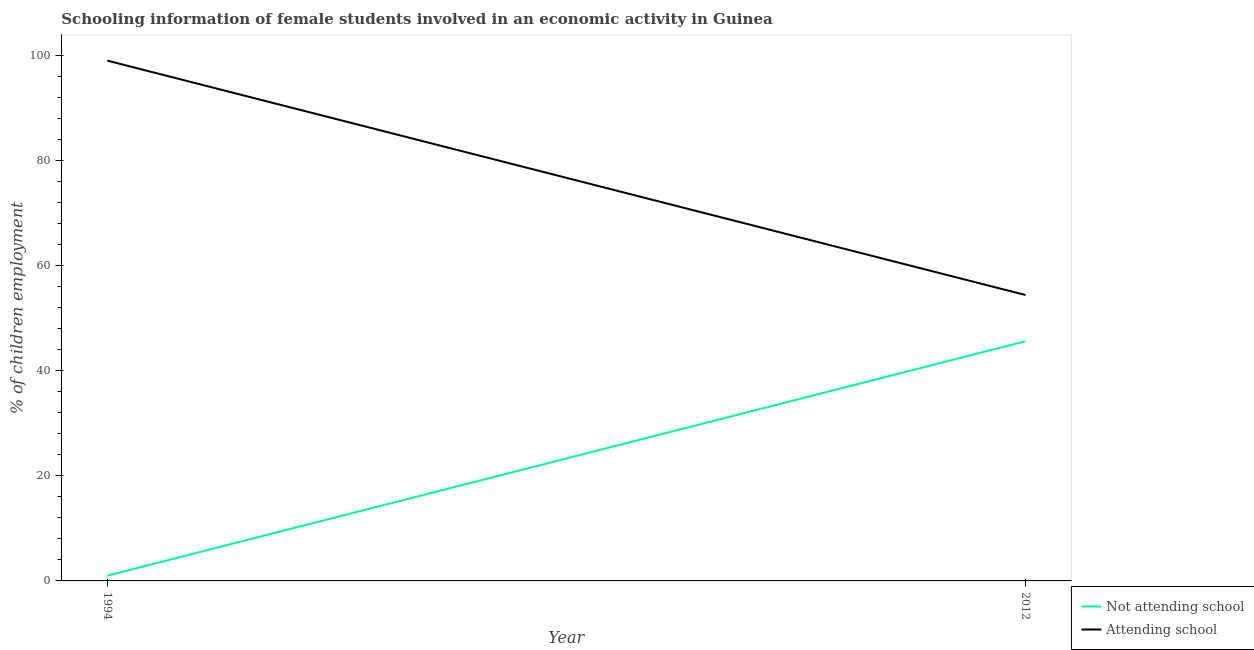How many different coloured lines are there?
Your answer should be very brief. 2. Across all years, what is the maximum percentage of employed females who are not attending school?
Keep it short and to the point. 45.6. In which year was the percentage of employed females who are attending school minimum?
Offer a very short reply. 2012. What is the total percentage of employed females who are not attending school in the graph?
Provide a succinct answer. 46.6. What is the difference between the percentage of employed females who are attending school in 1994 and that in 2012?
Your answer should be compact. 44.6. What is the difference between the percentage of employed females who are not attending school in 1994 and the percentage of employed females who are attending school in 2012?
Offer a very short reply. -53.4. What is the average percentage of employed females who are attending school per year?
Your response must be concise. 76.7. In the year 2012, what is the difference between the percentage of employed females who are attending school and percentage of employed females who are not attending school?
Make the answer very short. 8.8. What is the ratio of the percentage of employed females who are not attending school in 1994 to that in 2012?
Your answer should be compact. 0.02. Is the percentage of employed females who are attending school strictly greater than the percentage of employed females who are not attending school over the years?
Your answer should be very brief. Yes. How many lines are there?
Ensure brevity in your answer.  2. How many years are there in the graph?
Your response must be concise. 2. What is the difference between two consecutive major ticks on the Y-axis?
Give a very brief answer. 20. Are the values on the major ticks of Y-axis written in scientific E-notation?
Provide a short and direct response. No. Where does the legend appear in the graph?
Your answer should be compact. Bottom right. What is the title of the graph?
Ensure brevity in your answer.  Schooling information of female students involved in an economic activity in Guinea. Does "Highest 20% of population" appear as one of the legend labels in the graph?
Make the answer very short. No. What is the label or title of the Y-axis?
Your answer should be compact. % of children employment. What is the % of children employment in Not attending school in 2012?
Your response must be concise. 45.6. What is the % of children employment of Attending school in 2012?
Your answer should be compact. 54.4. Across all years, what is the maximum % of children employment in Not attending school?
Offer a terse response. 45.6. Across all years, what is the maximum % of children employment of Attending school?
Keep it short and to the point. 99. Across all years, what is the minimum % of children employment in Attending school?
Offer a very short reply. 54.4. What is the total % of children employment of Not attending school in the graph?
Ensure brevity in your answer.  46.6. What is the total % of children employment of Attending school in the graph?
Keep it short and to the point. 153.4. What is the difference between the % of children employment of Not attending school in 1994 and that in 2012?
Offer a terse response. -44.6. What is the difference between the % of children employment in Attending school in 1994 and that in 2012?
Provide a short and direct response. 44.6. What is the difference between the % of children employment of Not attending school in 1994 and the % of children employment of Attending school in 2012?
Ensure brevity in your answer.  -53.4. What is the average % of children employment of Not attending school per year?
Make the answer very short. 23.3. What is the average % of children employment in Attending school per year?
Your response must be concise. 76.7. In the year 1994, what is the difference between the % of children employment in Not attending school and % of children employment in Attending school?
Your response must be concise. -98. In the year 2012, what is the difference between the % of children employment in Not attending school and % of children employment in Attending school?
Provide a succinct answer. -8.8. What is the ratio of the % of children employment of Not attending school in 1994 to that in 2012?
Provide a succinct answer. 0.02. What is the ratio of the % of children employment of Attending school in 1994 to that in 2012?
Your answer should be very brief. 1.82. What is the difference between the highest and the second highest % of children employment in Not attending school?
Offer a very short reply. 44.6. What is the difference between the highest and the second highest % of children employment of Attending school?
Your answer should be very brief. 44.6. What is the difference between the highest and the lowest % of children employment in Not attending school?
Give a very brief answer. 44.6. What is the difference between the highest and the lowest % of children employment of Attending school?
Your answer should be very brief. 44.6. 